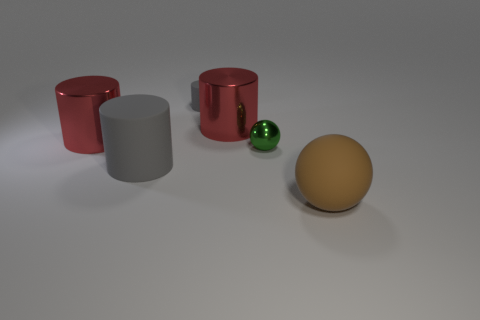There is a brown ball that is made of the same material as the tiny cylinder; what is its size?
Give a very brief answer. Large. Is there anything else of the same color as the tiny metallic object?
Ensure brevity in your answer.  No. Do the large brown thing and the gray cylinder that is behind the green metallic sphere have the same material?
Your answer should be compact. Yes. What material is the other gray object that is the same shape as the tiny rubber thing?
Your response must be concise. Rubber. Is there anything else that has the same material as the small gray thing?
Provide a short and direct response. Yes. Is the material of the sphere behind the brown sphere the same as the gray cylinder that is in front of the tiny metal object?
Offer a terse response. No. What is the color of the rubber thing that is behind the tiny object to the right of the large red metal cylinder to the right of the large matte cylinder?
Your answer should be compact. Gray. What number of other objects are the same shape as the small gray thing?
Ensure brevity in your answer.  3. Is the color of the big sphere the same as the tiny rubber thing?
Provide a succinct answer. No. How many objects are tiny green metal cubes or big things behind the big ball?
Your answer should be compact. 3. 